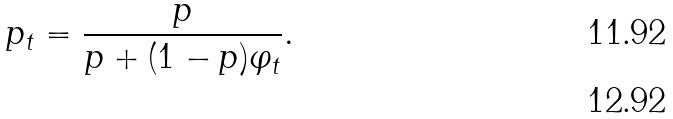<formula> <loc_0><loc_0><loc_500><loc_500>p _ { t } = \frac { p } { p + ( 1 - p ) \varphi _ { t } } . \\</formula> 